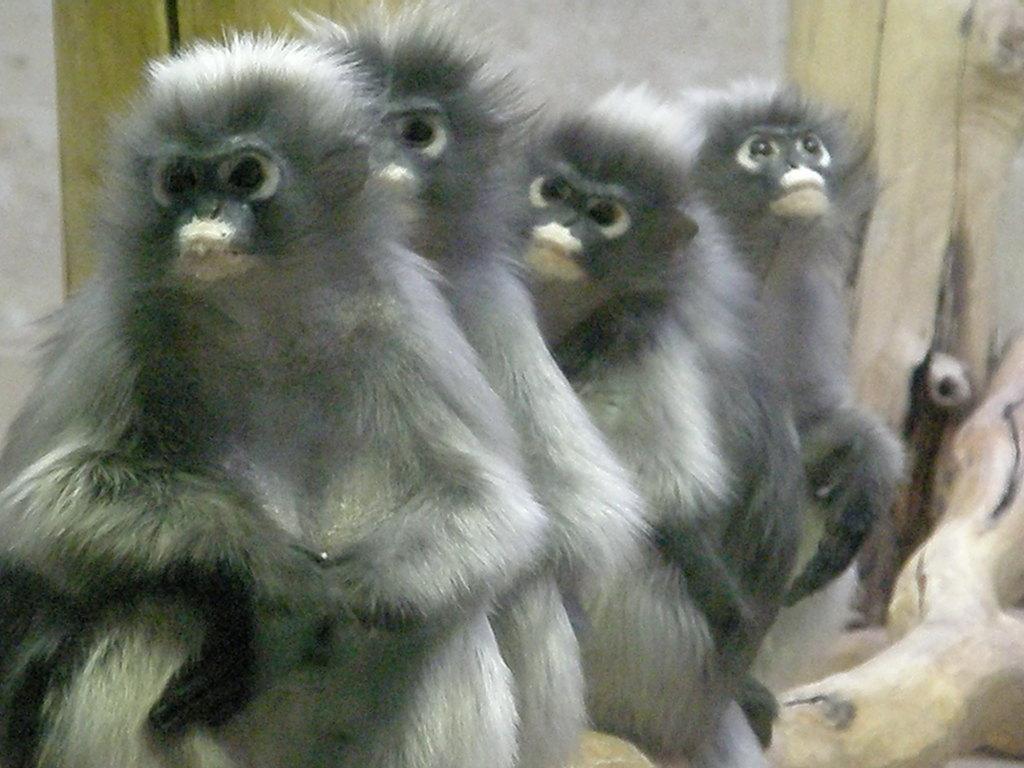Please provide a concise description of this image. In the picture I can see monkeys are sitting on the stem. 